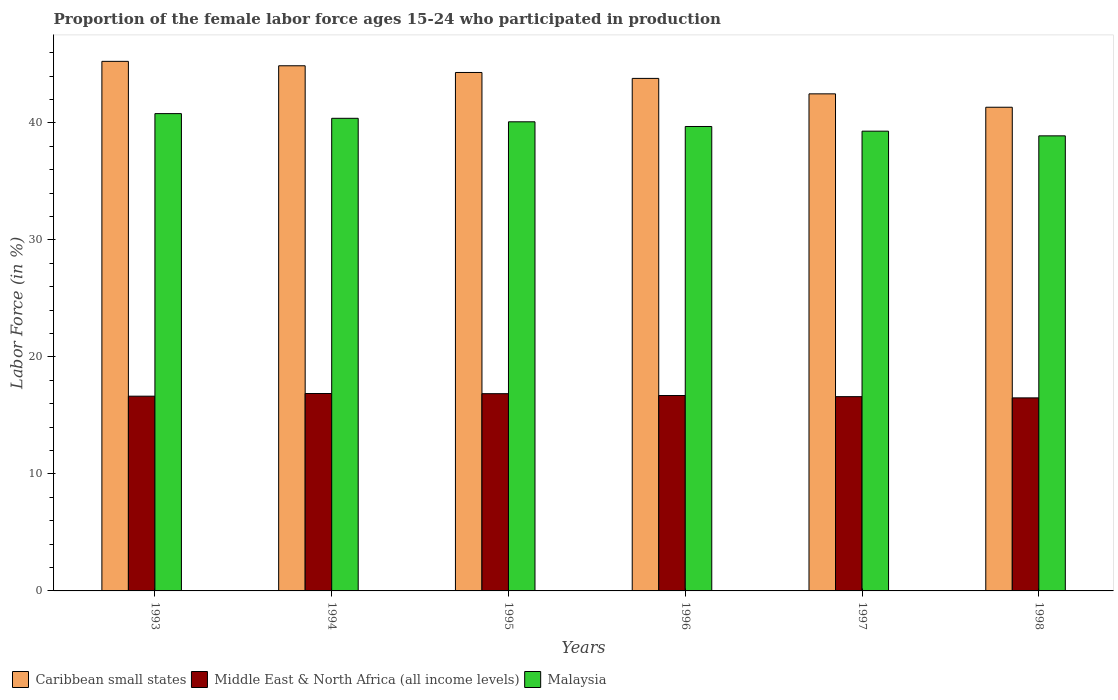How many different coloured bars are there?
Offer a terse response. 3. How many groups of bars are there?
Make the answer very short. 6. Are the number of bars on each tick of the X-axis equal?
Your answer should be compact. Yes. How many bars are there on the 3rd tick from the left?
Offer a very short reply. 3. In how many cases, is the number of bars for a given year not equal to the number of legend labels?
Provide a succinct answer. 0. What is the proportion of the female labor force who participated in production in Malaysia in 1998?
Your answer should be very brief. 38.9. Across all years, what is the maximum proportion of the female labor force who participated in production in Caribbean small states?
Provide a short and direct response. 45.27. Across all years, what is the minimum proportion of the female labor force who participated in production in Middle East & North Africa (all income levels)?
Provide a short and direct response. 16.5. In which year was the proportion of the female labor force who participated in production in Middle East & North Africa (all income levels) maximum?
Keep it short and to the point. 1994. In which year was the proportion of the female labor force who participated in production in Malaysia minimum?
Your answer should be compact. 1998. What is the total proportion of the female labor force who participated in production in Malaysia in the graph?
Provide a succinct answer. 239.2. What is the difference between the proportion of the female labor force who participated in production in Middle East & North Africa (all income levels) in 1994 and that in 1995?
Offer a very short reply. 0.02. What is the difference between the proportion of the female labor force who participated in production in Caribbean small states in 1997 and the proportion of the female labor force who participated in production in Middle East & North Africa (all income levels) in 1995?
Provide a short and direct response. 25.63. What is the average proportion of the female labor force who participated in production in Malaysia per year?
Give a very brief answer. 39.87. In the year 1996, what is the difference between the proportion of the female labor force who participated in production in Middle East & North Africa (all income levels) and proportion of the female labor force who participated in production in Caribbean small states?
Provide a short and direct response. -27.11. In how many years, is the proportion of the female labor force who participated in production in Malaysia greater than 28 %?
Ensure brevity in your answer.  6. What is the ratio of the proportion of the female labor force who participated in production in Malaysia in 1996 to that in 1998?
Provide a short and direct response. 1.02. Is the proportion of the female labor force who participated in production in Caribbean small states in 1993 less than that in 1998?
Make the answer very short. No. Is the difference between the proportion of the female labor force who participated in production in Middle East & North Africa (all income levels) in 1996 and 1997 greater than the difference between the proportion of the female labor force who participated in production in Caribbean small states in 1996 and 1997?
Your answer should be compact. No. What is the difference between the highest and the second highest proportion of the female labor force who participated in production in Middle East & North Africa (all income levels)?
Keep it short and to the point. 0.02. What is the difference between the highest and the lowest proportion of the female labor force who participated in production in Malaysia?
Offer a terse response. 1.9. Is the sum of the proportion of the female labor force who participated in production in Middle East & North Africa (all income levels) in 1997 and 1998 greater than the maximum proportion of the female labor force who participated in production in Caribbean small states across all years?
Provide a short and direct response. No. What does the 2nd bar from the left in 1997 represents?
Ensure brevity in your answer.  Middle East & North Africa (all income levels). What does the 2nd bar from the right in 1993 represents?
Your response must be concise. Middle East & North Africa (all income levels). Is it the case that in every year, the sum of the proportion of the female labor force who participated in production in Middle East & North Africa (all income levels) and proportion of the female labor force who participated in production in Malaysia is greater than the proportion of the female labor force who participated in production in Caribbean small states?
Your answer should be very brief. Yes. Are all the bars in the graph horizontal?
Provide a succinct answer. No. How many years are there in the graph?
Provide a short and direct response. 6. What is the difference between two consecutive major ticks on the Y-axis?
Make the answer very short. 10. Where does the legend appear in the graph?
Your answer should be very brief. Bottom left. What is the title of the graph?
Make the answer very short. Proportion of the female labor force ages 15-24 who participated in production. What is the Labor Force (in %) in Caribbean small states in 1993?
Your response must be concise. 45.27. What is the Labor Force (in %) in Middle East & North Africa (all income levels) in 1993?
Give a very brief answer. 16.65. What is the Labor Force (in %) of Malaysia in 1993?
Give a very brief answer. 40.8. What is the Labor Force (in %) of Caribbean small states in 1994?
Give a very brief answer. 44.89. What is the Labor Force (in %) of Middle East & North Africa (all income levels) in 1994?
Offer a terse response. 16.87. What is the Labor Force (in %) in Malaysia in 1994?
Keep it short and to the point. 40.4. What is the Labor Force (in %) in Caribbean small states in 1995?
Ensure brevity in your answer.  44.32. What is the Labor Force (in %) in Middle East & North Africa (all income levels) in 1995?
Ensure brevity in your answer.  16.86. What is the Labor Force (in %) of Malaysia in 1995?
Your answer should be compact. 40.1. What is the Labor Force (in %) in Caribbean small states in 1996?
Make the answer very short. 43.81. What is the Labor Force (in %) of Middle East & North Africa (all income levels) in 1996?
Provide a succinct answer. 16.7. What is the Labor Force (in %) in Malaysia in 1996?
Ensure brevity in your answer.  39.7. What is the Labor Force (in %) in Caribbean small states in 1997?
Provide a succinct answer. 42.49. What is the Labor Force (in %) of Middle East & North Africa (all income levels) in 1997?
Your answer should be very brief. 16.61. What is the Labor Force (in %) in Malaysia in 1997?
Make the answer very short. 39.3. What is the Labor Force (in %) of Caribbean small states in 1998?
Your response must be concise. 41.35. What is the Labor Force (in %) of Middle East & North Africa (all income levels) in 1998?
Your answer should be compact. 16.5. What is the Labor Force (in %) of Malaysia in 1998?
Provide a short and direct response. 38.9. Across all years, what is the maximum Labor Force (in %) in Caribbean small states?
Your answer should be very brief. 45.27. Across all years, what is the maximum Labor Force (in %) of Middle East & North Africa (all income levels)?
Keep it short and to the point. 16.87. Across all years, what is the maximum Labor Force (in %) in Malaysia?
Provide a short and direct response. 40.8. Across all years, what is the minimum Labor Force (in %) in Caribbean small states?
Offer a very short reply. 41.35. Across all years, what is the minimum Labor Force (in %) of Middle East & North Africa (all income levels)?
Provide a short and direct response. 16.5. Across all years, what is the minimum Labor Force (in %) of Malaysia?
Offer a terse response. 38.9. What is the total Labor Force (in %) of Caribbean small states in the graph?
Offer a terse response. 262.12. What is the total Labor Force (in %) of Middle East & North Africa (all income levels) in the graph?
Make the answer very short. 100.19. What is the total Labor Force (in %) of Malaysia in the graph?
Keep it short and to the point. 239.2. What is the difference between the Labor Force (in %) in Caribbean small states in 1993 and that in 1994?
Provide a succinct answer. 0.38. What is the difference between the Labor Force (in %) of Middle East & North Africa (all income levels) in 1993 and that in 1994?
Keep it short and to the point. -0.23. What is the difference between the Labor Force (in %) of Malaysia in 1993 and that in 1994?
Give a very brief answer. 0.4. What is the difference between the Labor Force (in %) in Caribbean small states in 1993 and that in 1995?
Your answer should be very brief. 0.95. What is the difference between the Labor Force (in %) in Middle East & North Africa (all income levels) in 1993 and that in 1995?
Make the answer very short. -0.21. What is the difference between the Labor Force (in %) of Caribbean small states in 1993 and that in 1996?
Your answer should be very brief. 1.46. What is the difference between the Labor Force (in %) in Middle East & North Africa (all income levels) in 1993 and that in 1996?
Ensure brevity in your answer.  -0.06. What is the difference between the Labor Force (in %) in Caribbean small states in 1993 and that in 1997?
Offer a terse response. 2.78. What is the difference between the Labor Force (in %) of Middle East & North Africa (all income levels) in 1993 and that in 1997?
Ensure brevity in your answer.  0.04. What is the difference between the Labor Force (in %) in Caribbean small states in 1993 and that in 1998?
Offer a very short reply. 3.92. What is the difference between the Labor Force (in %) in Middle East & North Africa (all income levels) in 1993 and that in 1998?
Ensure brevity in your answer.  0.14. What is the difference between the Labor Force (in %) of Malaysia in 1993 and that in 1998?
Your answer should be very brief. 1.9. What is the difference between the Labor Force (in %) of Caribbean small states in 1994 and that in 1995?
Give a very brief answer. 0.57. What is the difference between the Labor Force (in %) of Middle East & North Africa (all income levels) in 1994 and that in 1995?
Keep it short and to the point. 0.01. What is the difference between the Labor Force (in %) of Caribbean small states in 1994 and that in 1996?
Ensure brevity in your answer.  1.08. What is the difference between the Labor Force (in %) in Middle East & North Africa (all income levels) in 1994 and that in 1996?
Offer a terse response. 0.17. What is the difference between the Labor Force (in %) in Caribbean small states in 1994 and that in 1997?
Your response must be concise. 2.4. What is the difference between the Labor Force (in %) of Middle East & North Africa (all income levels) in 1994 and that in 1997?
Make the answer very short. 0.27. What is the difference between the Labor Force (in %) in Caribbean small states in 1994 and that in 1998?
Your answer should be very brief. 3.55. What is the difference between the Labor Force (in %) of Middle East & North Africa (all income levels) in 1994 and that in 1998?
Provide a succinct answer. 0.37. What is the difference between the Labor Force (in %) of Malaysia in 1994 and that in 1998?
Keep it short and to the point. 1.5. What is the difference between the Labor Force (in %) in Caribbean small states in 1995 and that in 1996?
Provide a succinct answer. 0.51. What is the difference between the Labor Force (in %) of Middle East & North Africa (all income levels) in 1995 and that in 1996?
Provide a succinct answer. 0.16. What is the difference between the Labor Force (in %) of Malaysia in 1995 and that in 1996?
Your response must be concise. 0.4. What is the difference between the Labor Force (in %) in Caribbean small states in 1995 and that in 1997?
Your answer should be very brief. 1.83. What is the difference between the Labor Force (in %) of Middle East & North Africa (all income levels) in 1995 and that in 1997?
Offer a terse response. 0.25. What is the difference between the Labor Force (in %) in Malaysia in 1995 and that in 1997?
Offer a very short reply. 0.8. What is the difference between the Labor Force (in %) of Caribbean small states in 1995 and that in 1998?
Ensure brevity in your answer.  2.97. What is the difference between the Labor Force (in %) of Middle East & North Africa (all income levels) in 1995 and that in 1998?
Offer a terse response. 0.36. What is the difference between the Labor Force (in %) of Malaysia in 1995 and that in 1998?
Give a very brief answer. 1.2. What is the difference between the Labor Force (in %) in Caribbean small states in 1996 and that in 1997?
Provide a succinct answer. 1.32. What is the difference between the Labor Force (in %) of Middle East & North Africa (all income levels) in 1996 and that in 1997?
Offer a very short reply. 0.1. What is the difference between the Labor Force (in %) in Caribbean small states in 1996 and that in 1998?
Ensure brevity in your answer.  2.46. What is the difference between the Labor Force (in %) in Middle East & North Africa (all income levels) in 1996 and that in 1998?
Your response must be concise. 0.2. What is the difference between the Labor Force (in %) in Caribbean small states in 1997 and that in 1998?
Your answer should be compact. 1.14. What is the difference between the Labor Force (in %) in Middle East & North Africa (all income levels) in 1997 and that in 1998?
Ensure brevity in your answer.  0.1. What is the difference between the Labor Force (in %) in Caribbean small states in 1993 and the Labor Force (in %) in Middle East & North Africa (all income levels) in 1994?
Offer a very short reply. 28.39. What is the difference between the Labor Force (in %) in Caribbean small states in 1993 and the Labor Force (in %) in Malaysia in 1994?
Your answer should be very brief. 4.87. What is the difference between the Labor Force (in %) of Middle East & North Africa (all income levels) in 1993 and the Labor Force (in %) of Malaysia in 1994?
Your response must be concise. -23.75. What is the difference between the Labor Force (in %) of Caribbean small states in 1993 and the Labor Force (in %) of Middle East & North Africa (all income levels) in 1995?
Offer a very short reply. 28.41. What is the difference between the Labor Force (in %) of Caribbean small states in 1993 and the Labor Force (in %) of Malaysia in 1995?
Your answer should be very brief. 5.17. What is the difference between the Labor Force (in %) in Middle East & North Africa (all income levels) in 1993 and the Labor Force (in %) in Malaysia in 1995?
Your answer should be compact. -23.45. What is the difference between the Labor Force (in %) in Caribbean small states in 1993 and the Labor Force (in %) in Middle East & North Africa (all income levels) in 1996?
Give a very brief answer. 28.57. What is the difference between the Labor Force (in %) in Caribbean small states in 1993 and the Labor Force (in %) in Malaysia in 1996?
Your response must be concise. 5.57. What is the difference between the Labor Force (in %) of Middle East & North Africa (all income levels) in 1993 and the Labor Force (in %) of Malaysia in 1996?
Ensure brevity in your answer.  -23.05. What is the difference between the Labor Force (in %) of Caribbean small states in 1993 and the Labor Force (in %) of Middle East & North Africa (all income levels) in 1997?
Ensure brevity in your answer.  28.66. What is the difference between the Labor Force (in %) in Caribbean small states in 1993 and the Labor Force (in %) in Malaysia in 1997?
Give a very brief answer. 5.97. What is the difference between the Labor Force (in %) in Middle East & North Africa (all income levels) in 1993 and the Labor Force (in %) in Malaysia in 1997?
Offer a very short reply. -22.65. What is the difference between the Labor Force (in %) of Caribbean small states in 1993 and the Labor Force (in %) of Middle East & North Africa (all income levels) in 1998?
Your response must be concise. 28.77. What is the difference between the Labor Force (in %) in Caribbean small states in 1993 and the Labor Force (in %) in Malaysia in 1998?
Ensure brevity in your answer.  6.37. What is the difference between the Labor Force (in %) of Middle East & North Africa (all income levels) in 1993 and the Labor Force (in %) of Malaysia in 1998?
Your response must be concise. -22.25. What is the difference between the Labor Force (in %) of Caribbean small states in 1994 and the Labor Force (in %) of Middle East & North Africa (all income levels) in 1995?
Your response must be concise. 28.03. What is the difference between the Labor Force (in %) in Caribbean small states in 1994 and the Labor Force (in %) in Malaysia in 1995?
Provide a short and direct response. 4.79. What is the difference between the Labor Force (in %) in Middle East & North Africa (all income levels) in 1994 and the Labor Force (in %) in Malaysia in 1995?
Your answer should be very brief. -23.23. What is the difference between the Labor Force (in %) of Caribbean small states in 1994 and the Labor Force (in %) of Middle East & North Africa (all income levels) in 1996?
Your answer should be very brief. 28.19. What is the difference between the Labor Force (in %) of Caribbean small states in 1994 and the Labor Force (in %) of Malaysia in 1996?
Keep it short and to the point. 5.19. What is the difference between the Labor Force (in %) in Middle East & North Africa (all income levels) in 1994 and the Labor Force (in %) in Malaysia in 1996?
Provide a succinct answer. -22.83. What is the difference between the Labor Force (in %) of Caribbean small states in 1994 and the Labor Force (in %) of Middle East & North Africa (all income levels) in 1997?
Your answer should be very brief. 28.28. What is the difference between the Labor Force (in %) in Caribbean small states in 1994 and the Labor Force (in %) in Malaysia in 1997?
Offer a terse response. 5.59. What is the difference between the Labor Force (in %) in Middle East & North Africa (all income levels) in 1994 and the Labor Force (in %) in Malaysia in 1997?
Give a very brief answer. -22.43. What is the difference between the Labor Force (in %) in Caribbean small states in 1994 and the Labor Force (in %) in Middle East & North Africa (all income levels) in 1998?
Your answer should be very brief. 28.39. What is the difference between the Labor Force (in %) of Caribbean small states in 1994 and the Labor Force (in %) of Malaysia in 1998?
Keep it short and to the point. 5.99. What is the difference between the Labor Force (in %) of Middle East & North Africa (all income levels) in 1994 and the Labor Force (in %) of Malaysia in 1998?
Keep it short and to the point. -22.03. What is the difference between the Labor Force (in %) of Caribbean small states in 1995 and the Labor Force (in %) of Middle East & North Africa (all income levels) in 1996?
Your response must be concise. 27.61. What is the difference between the Labor Force (in %) of Caribbean small states in 1995 and the Labor Force (in %) of Malaysia in 1996?
Provide a succinct answer. 4.62. What is the difference between the Labor Force (in %) in Middle East & North Africa (all income levels) in 1995 and the Labor Force (in %) in Malaysia in 1996?
Make the answer very short. -22.84. What is the difference between the Labor Force (in %) in Caribbean small states in 1995 and the Labor Force (in %) in Middle East & North Africa (all income levels) in 1997?
Ensure brevity in your answer.  27.71. What is the difference between the Labor Force (in %) of Caribbean small states in 1995 and the Labor Force (in %) of Malaysia in 1997?
Your response must be concise. 5.02. What is the difference between the Labor Force (in %) of Middle East & North Africa (all income levels) in 1995 and the Labor Force (in %) of Malaysia in 1997?
Make the answer very short. -22.44. What is the difference between the Labor Force (in %) of Caribbean small states in 1995 and the Labor Force (in %) of Middle East & North Africa (all income levels) in 1998?
Provide a succinct answer. 27.82. What is the difference between the Labor Force (in %) in Caribbean small states in 1995 and the Labor Force (in %) in Malaysia in 1998?
Give a very brief answer. 5.42. What is the difference between the Labor Force (in %) in Middle East & North Africa (all income levels) in 1995 and the Labor Force (in %) in Malaysia in 1998?
Your answer should be compact. -22.04. What is the difference between the Labor Force (in %) of Caribbean small states in 1996 and the Labor Force (in %) of Middle East & North Africa (all income levels) in 1997?
Ensure brevity in your answer.  27.2. What is the difference between the Labor Force (in %) in Caribbean small states in 1996 and the Labor Force (in %) in Malaysia in 1997?
Provide a succinct answer. 4.51. What is the difference between the Labor Force (in %) in Middle East & North Africa (all income levels) in 1996 and the Labor Force (in %) in Malaysia in 1997?
Offer a very short reply. -22.6. What is the difference between the Labor Force (in %) of Caribbean small states in 1996 and the Labor Force (in %) of Middle East & North Africa (all income levels) in 1998?
Offer a terse response. 27.31. What is the difference between the Labor Force (in %) in Caribbean small states in 1996 and the Labor Force (in %) in Malaysia in 1998?
Keep it short and to the point. 4.91. What is the difference between the Labor Force (in %) in Middle East & North Africa (all income levels) in 1996 and the Labor Force (in %) in Malaysia in 1998?
Your answer should be compact. -22.2. What is the difference between the Labor Force (in %) in Caribbean small states in 1997 and the Labor Force (in %) in Middle East & North Africa (all income levels) in 1998?
Provide a succinct answer. 25.99. What is the difference between the Labor Force (in %) of Caribbean small states in 1997 and the Labor Force (in %) of Malaysia in 1998?
Keep it short and to the point. 3.59. What is the difference between the Labor Force (in %) in Middle East & North Africa (all income levels) in 1997 and the Labor Force (in %) in Malaysia in 1998?
Your answer should be compact. -22.29. What is the average Labor Force (in %) in Caribbean small states per year?
Provide a succinct answer. 43.69. What is the average Labor Force (in %) of Middle East & North Africa (all income levels) per year?
Give a very brief answer. 16.7. What is the average Labor Force (in %) in Malaysia per year?
Give a very brief answer. 39.87. In the year 1993, what is the difference between the Labor Force (in %) of Caribbean small states and Labor Force (in %) of Middle East & North Africa (all income levels)?
Provide a succinct answer. 28.62. In the year 1993, what is the difference between the Labor Force (in %) in Caribbean small states and Labor Force (in %) in Malaysia?
Your answer should be compact. 4.47. In the year 1993, what is the difference between the Labor Force (in %) in Middle East & North Africa (all income levels) and Labor Force (in %) in Malaysia?
Offer a very short reply. -24.15. In the year 1994, what is the difference between the Labor Force (in %) in Caribbean small states and Labor Force (in %) in Middle East & North Africa (all income levels)?
Offer a very short reply. 28.02. In the year 1994, what is the difference between the Labor Force (in %) of Caribbean small states and Labor Force (in %) of Malaysia?
Offer a terse response. 4.49. In the year 1994, what is the difference between the Labor Force (in %) in Middle East & North Africa (all income levels) and Labor Force (in %) in Malaysia?
Offer a very short reply. -23.53. In the year 1995, what is the difference between the Labor Force (in %) of Caribbean small states and Labor Force (in %) of Middle East & North Africa (all income levels)?
Provide a succinct answer. 27.46. In the year 1995, what is the difference between the Labor Force (in %) in Caribbean small states and Labor Force (in %) in Malaysia?
Ensure brevity in your answer.  4.22. In the year 1995, what is the difference between the Labor Force (in %) of Middle East & North Africa (all income levels) and Labor Force (in %) of Malaysia?
Keep it short and to the point. -23.24. In the year 1996, what is the difference between the Labor Force (in %) in Caribbean small states and Labor Force (in %) in Middle East & North Africa (all income levels)?
Ensure brevity in your answer.  27.11. In the year 1996, what is the difference between the Labor Force (in %) of Caribbean small states and Labor Force (in %) of Malaysia?
Your response must be concise. 4.11. In the year 1996, what is the difference between the Labor Force (in %) of Middle East & North Africa (all income levels) and Labor Force (in %) of Malaysia?
Keep it short and to the point. -23. In the year 1997, what is the difference between the Labor Force (in %) in Caribbean small states and Labor Force (in %) in Middle East & North Africa (all income levels)?
Make the answer very short. 25.88. In the year 1997, what is the difference between the Labor Force (in %) of Caribbean small states and Labor Force (in %) of Malaysia?
Keep it short and to the point. 3.19. In the year 1997, what is the difference between the Labor Force (in %) in Middle East & North Africa (all income levels) and Labor Force (in %) in Malaysia?
Keep it short and to the point. -22.69. In the year 1998, what is the difference between the Labor Force (in %) of Caribbean small states and Labor Force (in %) of Middle East & North Africa (all income levels)?
Give a very brief answer. 24.84. In the year 1998, what is the difference between the Labor Force (in %) of Caribbean small states and Labor Force (in %) of Malaysia?
Ensure brevity in your answer.  2.45. In the year 1998, what is the difference between the Labor Force (in %) in Middle East & North Africa (all income levels) and Labor Force (in %) in Malaysia?
Provide a short and direct response. -22.4. What is the ratio of the Labor Force (in %) in Caribbean small states in 1993 to that in 1994?
Your response must be concise. 1.01. What is the ratio of the Labor Force (in %) of Middle East & North Africa (all income levels) in 1993 to that in 1994?
Keep it short and to the point. 0.99. What is the ratio of the Labor Force (in %) of Malaysia in 1993 to that in 1994?
Your response must be concise. 1.01. What is the ratio of the Labor Force (in %) in Caribbean small states in 1993 to that in 1995?
Provide a succinct answer. 1.02. What is the ratio of the Labor Force (in %) of Middle East & North Africa (all income levels) in 1993 to that in 1995?
Your answer should be compact. 0.99. What is the ratio of the Labor Force (in %) in Malaysia in 1993 to that in 1995?
Offer a very short reply. 1.02. What is the ratio of the Labor Force (in %) in Malaysia in 1993 to that in 1996?
Offer a terse response. 1.03. What is the ratio of the Labor Force (in %) in Caribbean small states in 1993 to that in 1997?
Your answer should be compact. 1.07. What is the ratio of the Labor Force (in %) of Malaysia in 1993 to that in 1997?
Offer a terse response. 1.04. What is the ratio of the Labor Force (in %) in Caribbean small states in 1993 to that in 1998?
Your response must be concise. 1.09. What is the ratio of the Labor Force (in %) in Middle East & North Africa (all income levels) in 1993 to that in 1998?
Make the answer very short. 1.01. What is the ratio of the Labor Force (in %) of Malaysia in 1993 to that in 1998?
Your answer should be compact. 1.05. What is the ratio of the Labor Force (in %) of Malaysia in 1994 to that in 1995?
Ensure brevity in your answer.  1.01. What is the ratio of the Labor Force (in %) of Caribbean small states in 1994 to that in 1996?
Your answer should be compact. 1.02. What is the ratio of the Labor Force (in %) of Middle East & North Africa (all income levels) in 1994 to that in 1996?
Your answer should be compact. 1.01. What is the ratio of the Labor Force (in %) of Malaysia in 1994 to that in 1996?
Offer a terse response. 1.02. What is the ratio of the Labor Force (in %) in Caribbean small states in 1994 to that in 1997?
Offer a very short reply. 1.06. What is the ratio of the Labor Force (in %) of Middle East & North Africa (all income levels) in 1994 to that in 1997?
Your answer should be compact. 1.02. What is the ratio of the Labor Force (in %) in Malaysia in 1994 to that in 1997?
Provide a short and direct response. 1.03. What is the ratio of the Labor Force (in %) in Caribbean small states in 1994 to that in 1998?
Make the answer very short. 1.09. What is the ratio of the Labor Force (in %) in Middle East & North Africa (all income levels) in 1994 to that in 1998?
Provide a short and direct response. 1.02. What is the ratio of the Labor Force (in %) of Malaysia in 1994 to that in 1998?
Offer a very short reply. 1.04. What is the ratio of the Labor Force (in %) of Caribbean small states in 1995 to that in 1996?
Make the answer very short. 1.01. What is the ratio of the Labor Force (in %) of Middle East & North Africa (all income levels) in 1995 to that in 1996?
Make the answer very short. 1.01. What is the ratio of the Labor Force (in %) in Caribbean small states in 1995 to that in 1997?
Your response must be concise. 1.04. What is the ratio of the Labor Force (in %) in Middle East & North Africa (all income levels) in 1995 to that in 1997?
Make the answer very short. 1.02. What is the ratio of the Labor Force (in %) of Malaysia in 1995 to that in 1997?
Keep it short and to the point. 1.02. What is the ratio of the Labor Force (in %) in Caribbean small states in 1995 to that in 1998?
Give a very brief answer. 1.07. What is the ratio of the Labor Force (in %) of Middle East & North Africa (all income levels) in 1995 to that in 1998?
Your answer should be very brief. 1.02. What is the ratio of the Labor Force (in %) in Malaysia in 1995 to that in 1998?
Your response must be concise. 1.03. What is the ratio of the Labor Force (in %) in Caribbean small states in 1996 to that in 1997?
Provide a short and direct response. 1.03. What is the ratio of the Labor Force (in %) of Middle East & North Africa (all income levels) in 1996 to that in 1997?
Provide a succinct answer. 1.01. What is the ratio of the Labor Force (in %) in Malaysia in 1996 to that in 1997?
Keep it short and to the point. 1.01. What is the ratio of the Labor Force (in %) of Caribbean small states in 1996 to that in 1998?
Offer a terse response. 1.06. What is the ratio of the Labor Force (in %) of Middle East & North Africa (all income levels) in 1996 to that in 1998?
Make the answer very short. 1.01. What is the ratio of the Labor Force (in %) of Malaysia in 1996 to that in 1998?
Provide a short and direct response. 1.02. What is the ratio of the Labor Force (in %) in Caribbean small states in 1997 to that in 1998?
Make the answer very short. 1.03. What is the ratio of the Labor Force (in %) in Middle East & North Africa (all income levels) in 1997 to that in 1998?
Provide a short and direct response. 1.01. What is the ratio of the Labor Force (in %) of Malaysia in 1997 to that in 1998?
Your answer should be very brief. 1.01. What is the difference between the highest and the second highest Labor Force (in %) in Caribbean small states?
Make the answer very short. 0.38. What is the difference between the highest and the second highest Labor Force (in %) in Middle East & North Africa (all income levels)?
Your response must be concise. 0.01. What is the difference between the highest and the lowest Labor Force (in %) in Caribbean small states?
Offer a terse response. 3.92. What is the difference between the highest and the lowest Labor Force (in %) of Middle East & North Africa (all income levels)?
Make the answer very short. 0.37. What is the difference between the highest and the lowest Labor Force (in %) in Malaysia?
Give a very brief answer. 1.9. 